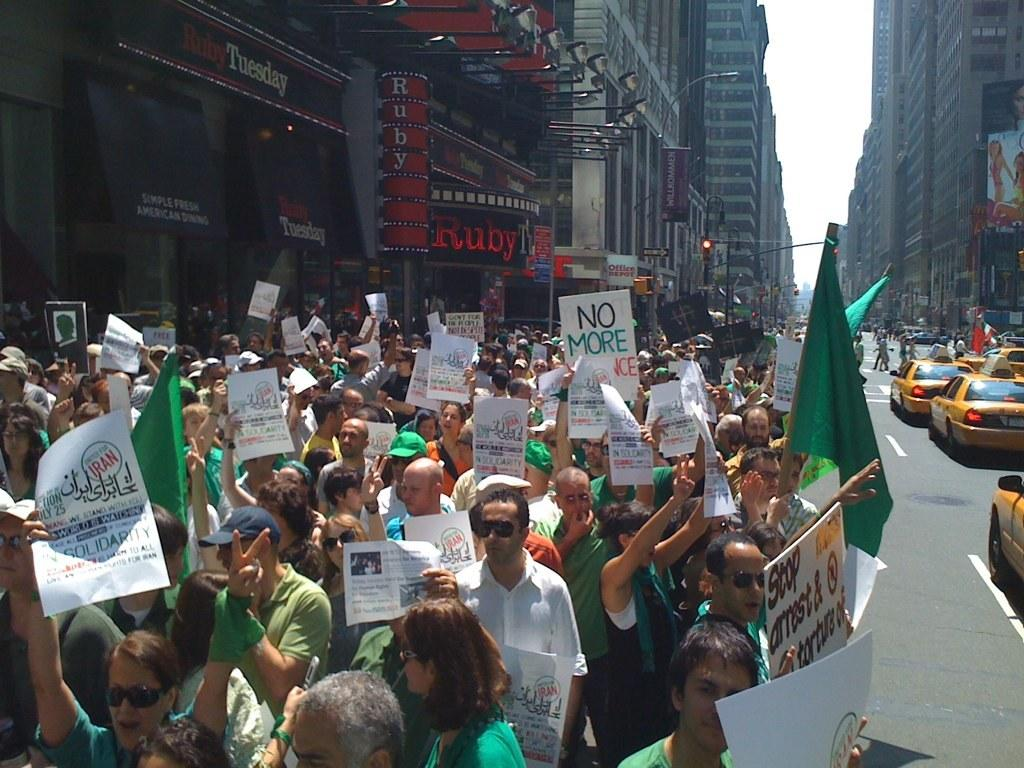Provide a one-sentence caption for the provided image. A group of protesters are outside of Ruby Tuesday. 